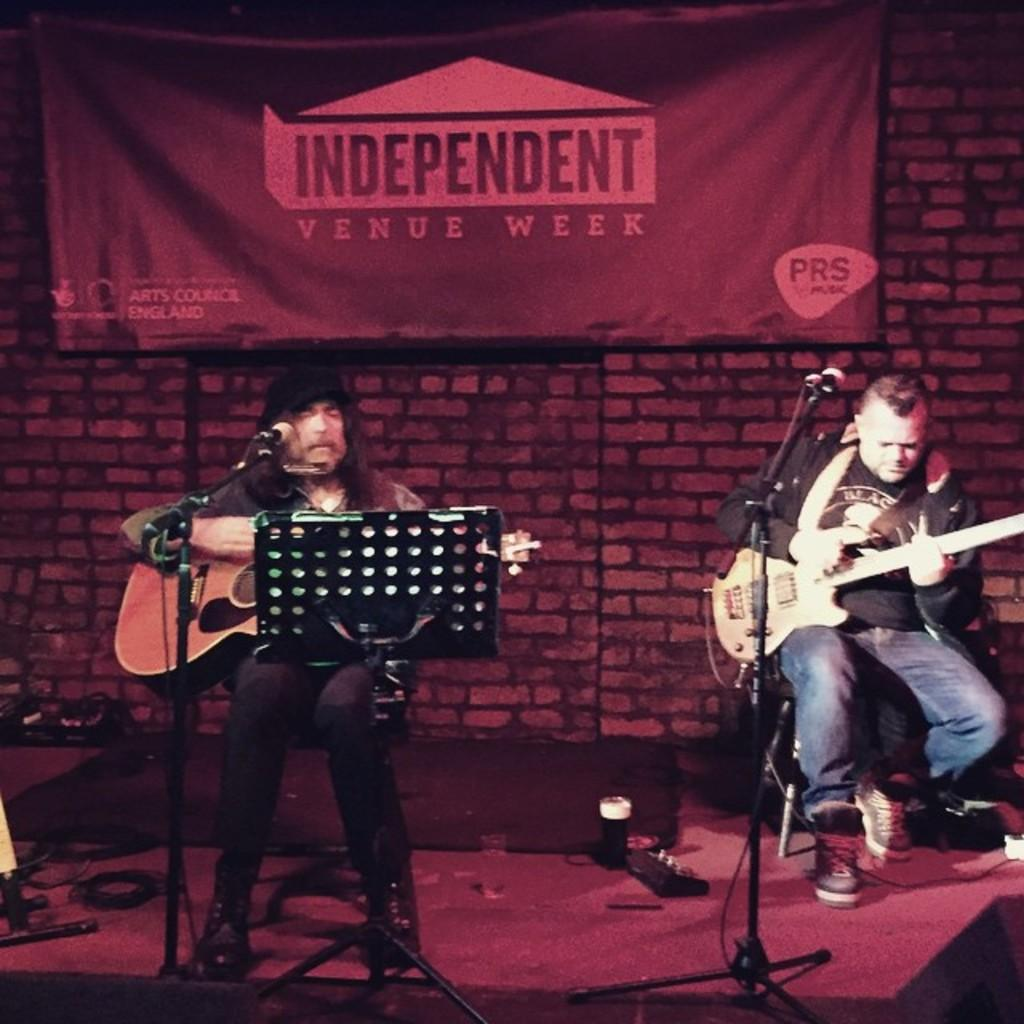How many people are in the image? There are two men in the image. What are the men doing in the image? The men are sitting on a chair and playing guitar. Where are the men located in the image? The men are in front of a microphone and on a stage. What type of ball is being used by the men in the image? There is no ball present in the image; the men are playing guitar. 